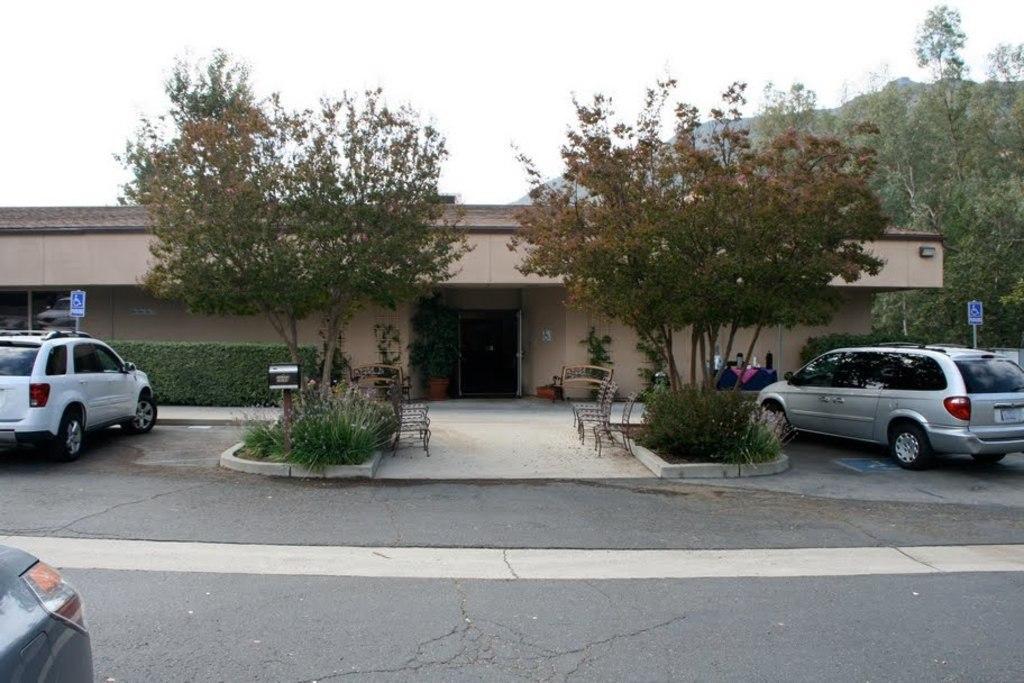In one or two sentences, can you explain what this image depicts? In this picture I can see some vehicles are placed side of the road, in front of the house and some benches, some trees are around. 